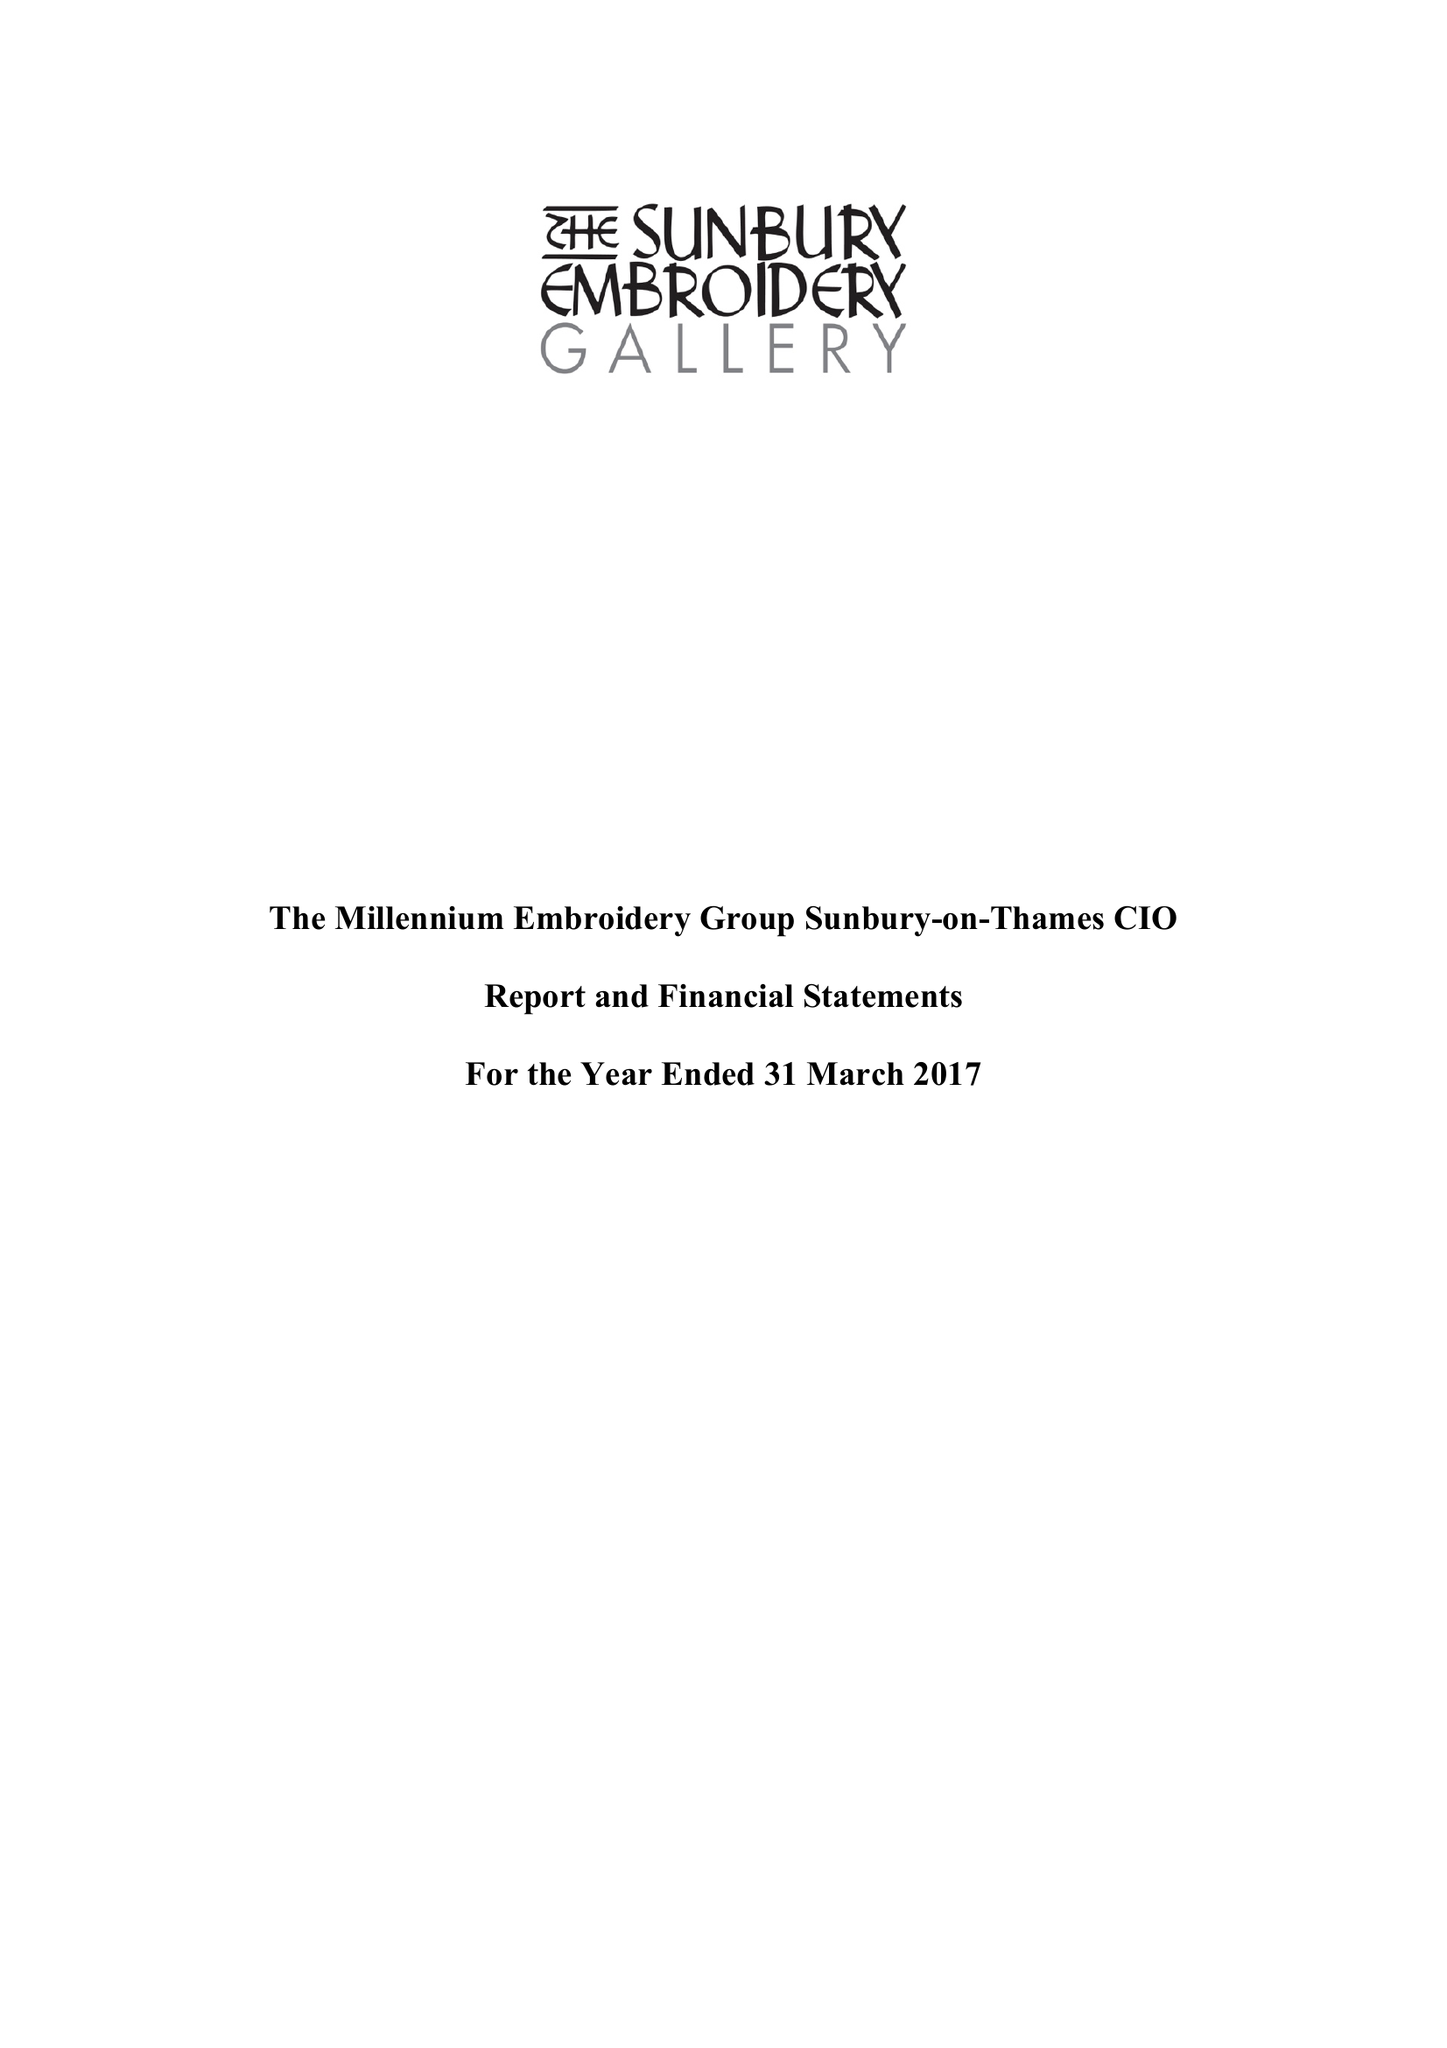What is the value for the spending_annually_in_british_pounds?
Answer the question using a single word or phrase. 172156.00 